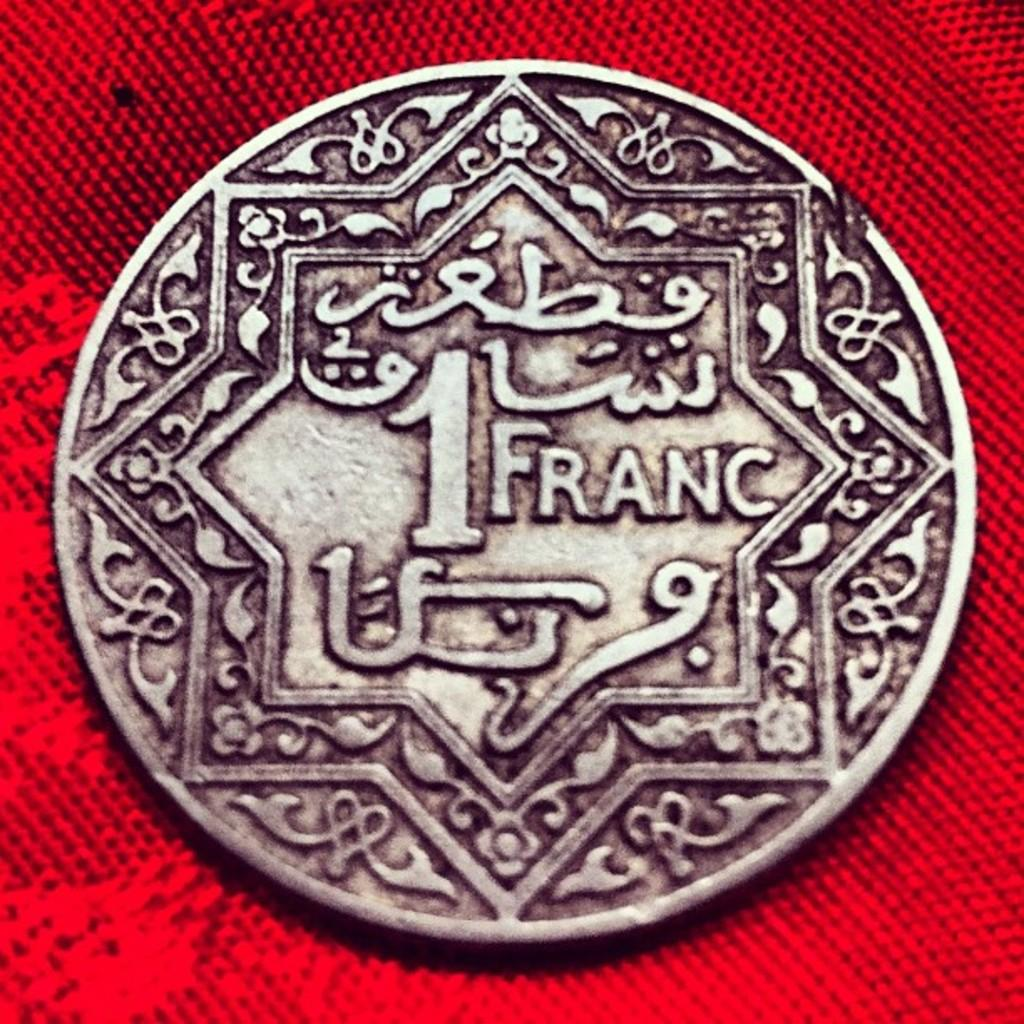<image>
Provide a brief description of the given image. A silver coin with the number 1 in Franc 